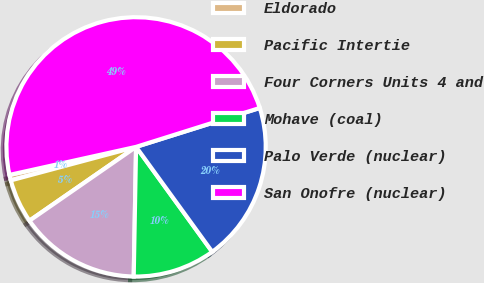Convert chart to OTSL. <chart><loc_0><loc_0><loc_500><loc_500><pie_chart><fcel>Eldorado<fcel>Pacific Intertie<fcel>Four Corners Units 4 and<fcel>Mohave (coal)<fcel>Palo Verde (nuclear)<fcel>San Onofre (nuclear)<nl><fcel>0.69%<fcel>5.48%<fcel>15.07%<fcel>10.28%<fcel>19.86%<fcel>48.62%<nl></chart> 